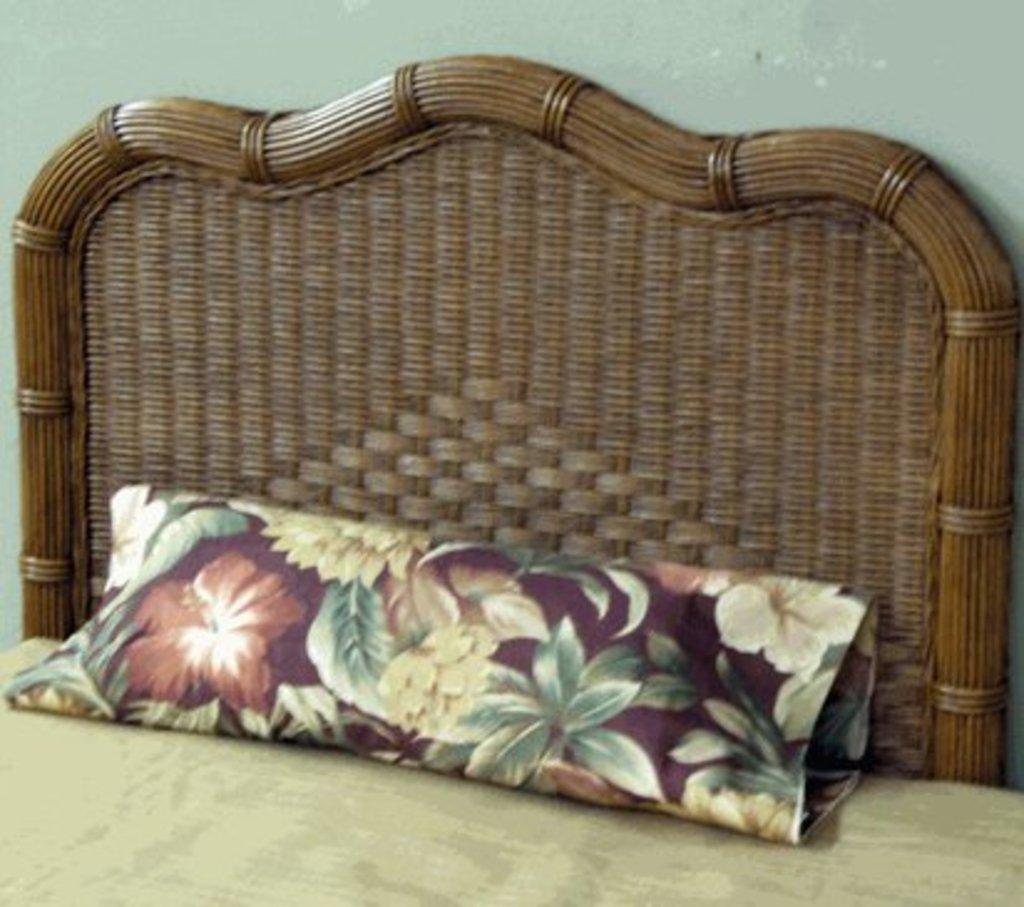What type of furniture is present in the image? There is a bed in the image. What is placed on the bed? There is a pillow on the bed. What type of bikes can be seen in the image? There are no bikes present in the image. Is the bed located in a hospital room in the image? The image does not provide any information about the location or context of the bed, so it cannot be determined if it is in a hospital room. 